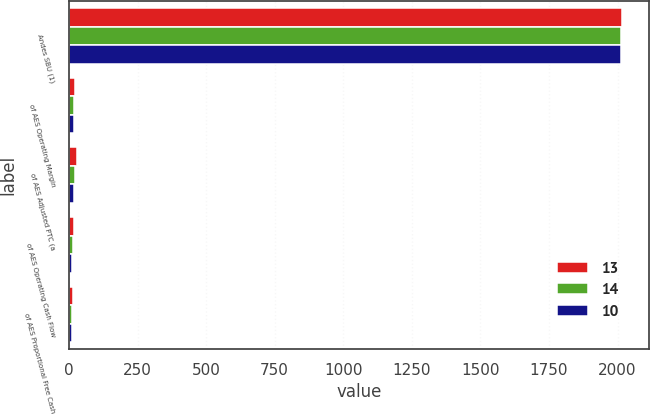<chart> <loc_0><loc_0><loc_500><loc_500><stacked_bar_chart><ecel><fcel>Andes SBU (1)<fcel>of AES Operating Margin<fcel>of AES Adjusted PTC (a<fcel>of AES Operating Cash Flow<fcel>of AES Proportional Free Cash<nl><fcel>13<fcel>2015<fcel>22<fcel>30<fcel>18<fcel>14<nl><fcel>14<fcel>2014<fcel>19<fcel>23<fcel>16<fcel>13<nl><fcel>10<fcel>2013<fcel>17<fcel>19<fcel>11<fcel>10<nl></chart> 